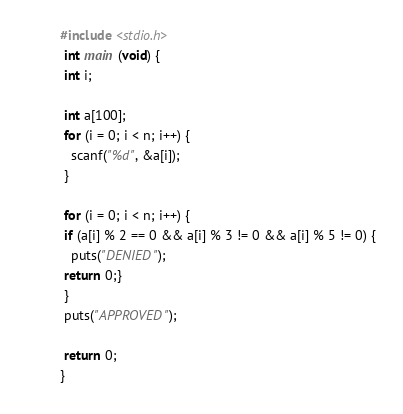<code> <loc_0><loc_0><loc_500><loc_500><_C_>#include <stdio.h>
 int main (void) {
 int i;

 int a[100];
 for (i = 0; i < n; i++) {
   scanf("%d", &a[i]);
 }

 for (i = 0; i < n; i++) {
 if (a[i] % 2 == 0 && a[i] % 3 != 0 && a[i] % 5 != 0) {
   puts("DENIED");
 return 0;}
 }
 puts("APPROVED");

 return 0;
}</code> 